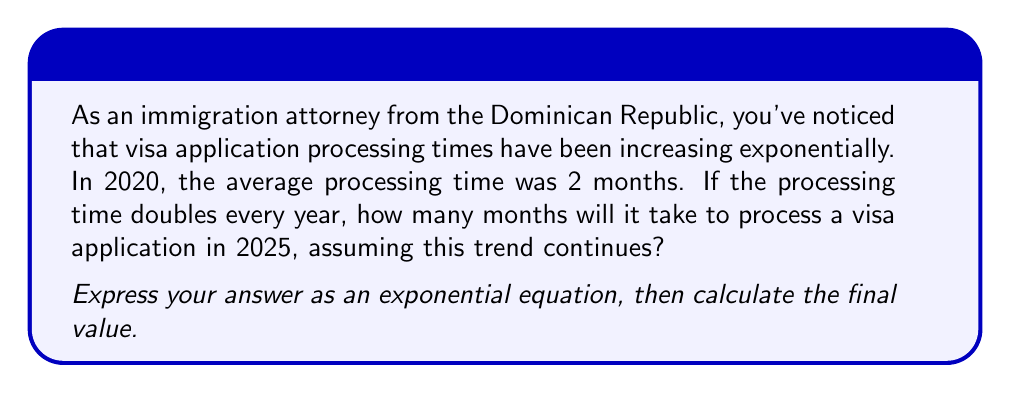Solve this math problem. Let's approach this step-by-step:

1) First, we need to identify the key components of our exponential equation:
   - Initial value (a): 2 months (in 2020)
   - Growth factor (r): 2 (doubles each year)
   - Time (t): 5 years (from 2020 to 2025)

2) The general form of an exponential growth equation is:
   $$ y = a \cdot r^t $$
   Where y is the final value, a is the initial value, r is the growth factor, and t is the time.

3) Plugging in our values:
   $$ y = 2 \cdot 2^5 $$

4) To calculate this:
   $$ y = 2 \cdot 2^5 = 2 \cdot 32 = 64 $$

5) Therefore, in 2025, it will take 64 months to process a visa application.

This exponential growth demonstrates how quickly processing times can escalate if they double each year, which is a critical concern for immigration attorneys and their clients.
Answer: $$ y = 2 \cdot 2^5 = 64 \text{ months} $$ 